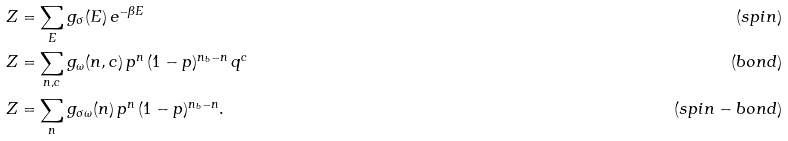<formula> <loc_0><loc_0><loc_500><loc_500>Z & = \sum _ { E } { g _ { \sigma } ( E ) \, e ^ { - \beta E } } & ( s p i n ) \\ Z & = \sum _ { n , c } { g _ { \omega } ( n , c ) \, p ^ { n } \, ( 1 - p ) ^ { n _ { b } - n } \, q ^ { c } } & ( b o n d ) \\ Z & = \sum _ { n } g _ { \sigma \omega } ( n ) \, p ^ { n } \, ( 1 - p ) ^ { n _ { b } - n } . & ( s p i n - b o n d )</formula> 